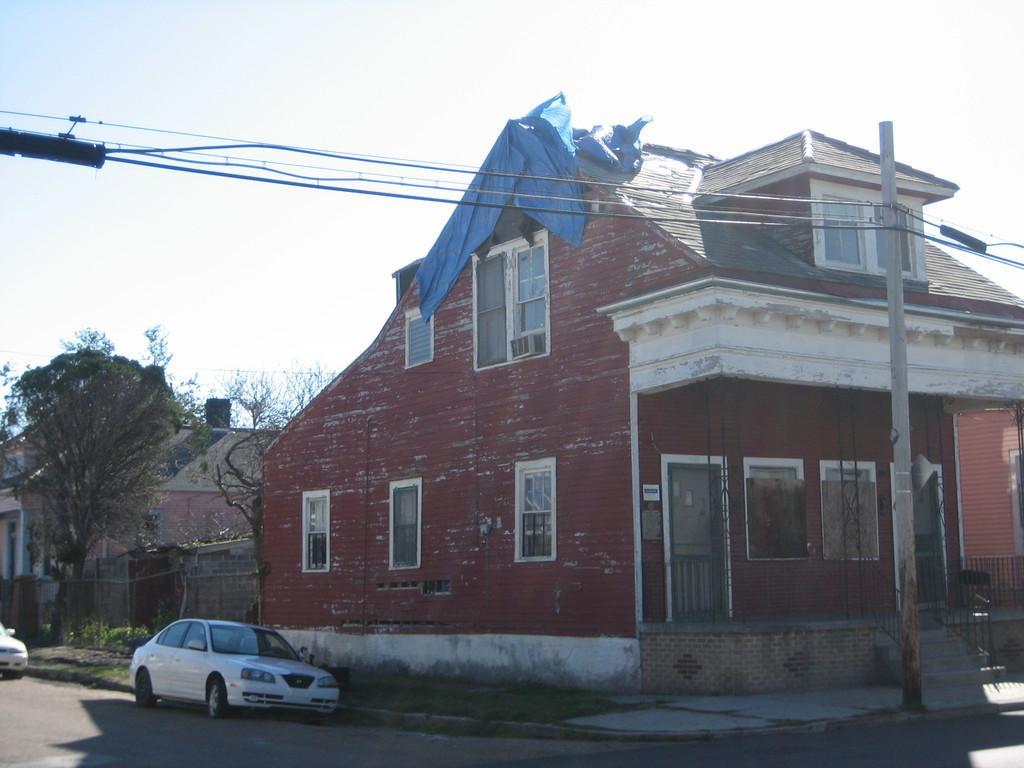What can be seen parked on the side of the road in the image? There are cars parked on the side of the road in the image. What type of structures are visible in the image? There are houses in the image. What objects can be seen supporting wires in the image? There are poles in the image. What is present alongside the poles in the image? There are wires in the image. What type of vegetation is visible in the image? There are trees in the image. What is visible in the background of the image? The sky is visible in the background of the image, and it appears to be plain. What type of head is visible on the trees in the image? There are no heads visible on the trees in the image; only the trees themselves are present. What selection of fruits can be seen hanging from the wires in the image? There are no fruits hanging from the wires in the image; only wires and poles are present. 